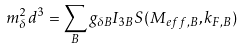<formula> <loc_0><loc_0><loc_500><loc_500>m _ { \delta } ^ { 2 } d ^ { 3 } = \sum _ { B } g _ { \delta B } I _ { 3 B } S ( M _ { e f f , B } , k _ { F , B } )</formula> 